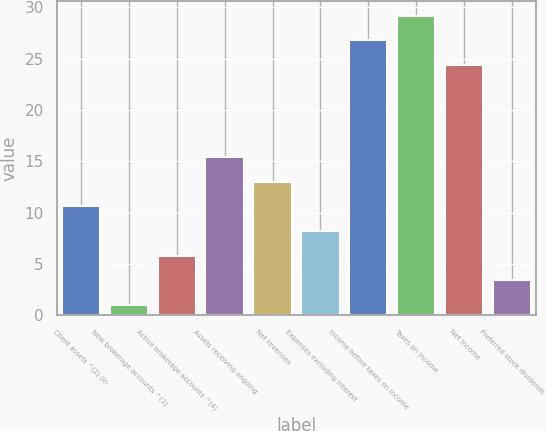Convert chart. <chart><loc_0><loc_0><loc_500><loc_500><bar_chart><fcel>Client assets ^(2) (in<fcel>New brokerage accounts ^(3)<fcel>Active brokerage accounts ^(4)<fcel>Assets receiving ongoing<fcel>Net revenues<fcel>Expenses excluding interest<fcel>Income before taxes on income<fcel>Taxes on income<fcel>Net income<fcel>Preferred stock dividends<nl><fcel>10.6<fcel>1<fcel>5.8<fcel>15.4<fcel>13<fcel>8.2<fcel>26.8<fcel>29.2<fcel>24.4<fcel>3.4<nl></chart> 